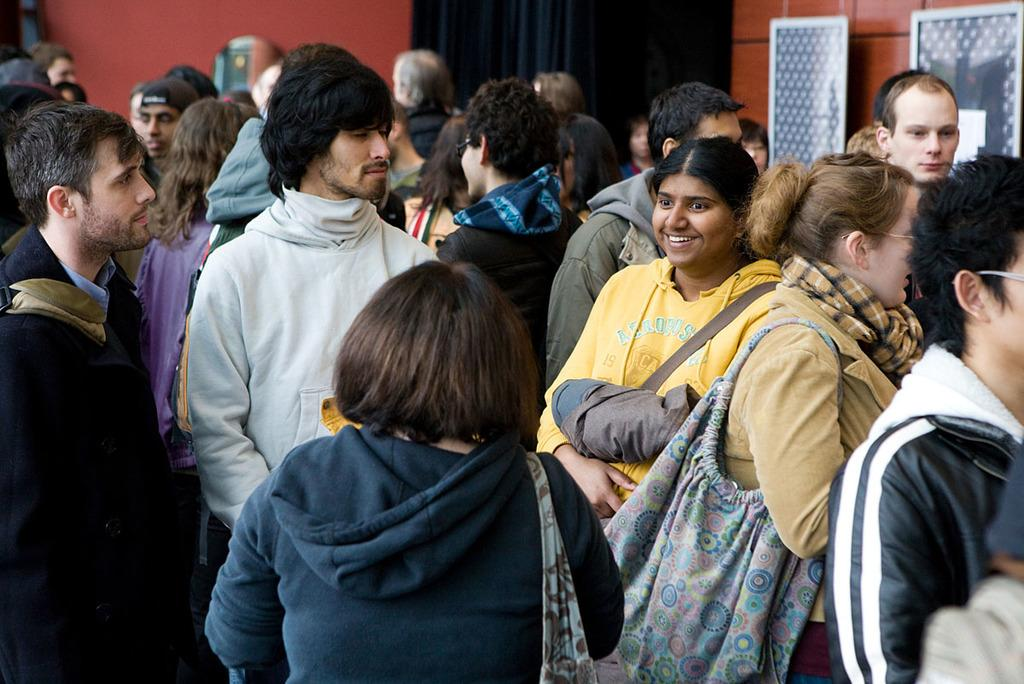What can be seen in the image? There are people standing in the image. What is visible in the background? There is a wall in the background of the image, and a curtain is associated with the wall. What objects are on the right side of the image? There are two boards on the right side of the image, and a woman is carrying a bag. Can you see an expert using a rifle in the image? There is no expert or rifle present in the image. Is there a spark visible in the image? There is no spark visible in the image. 